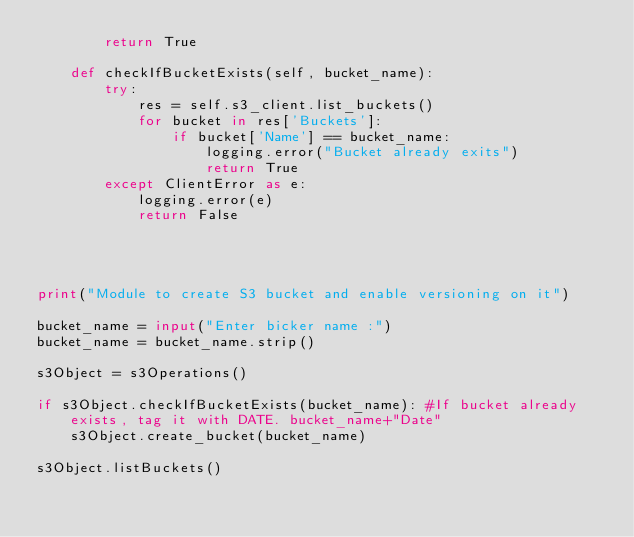Convert code to text. <code><loc_0><loc_0><loc_500><loc_500><_Python_>        return True

    def checkIfBucketExists(self, bucket_name):
        try:
            res = self.s3_client.list_buckets()
            for bucket in res['Buckets']:
                if bucket['Name'] == bucket_name:
                    logging.error("Bucket already exits")
                    return True
        except ClientError as e:
            logging.error(e)
            return False




print("Module to create S3 bucket and enable versioning on it")

bucket_name = input("Enter bicker name :")
bucket_name = bucket_name.strip()

s3Object = s3Operations()

if s3Object.checkIfBucketExists(bucket_name): #If bucket already exists, tag it with DATE. bucket_name+"Date"
    s3Object.create_bucket(bucket_name)

s3Object.listBuckets()



</code> 